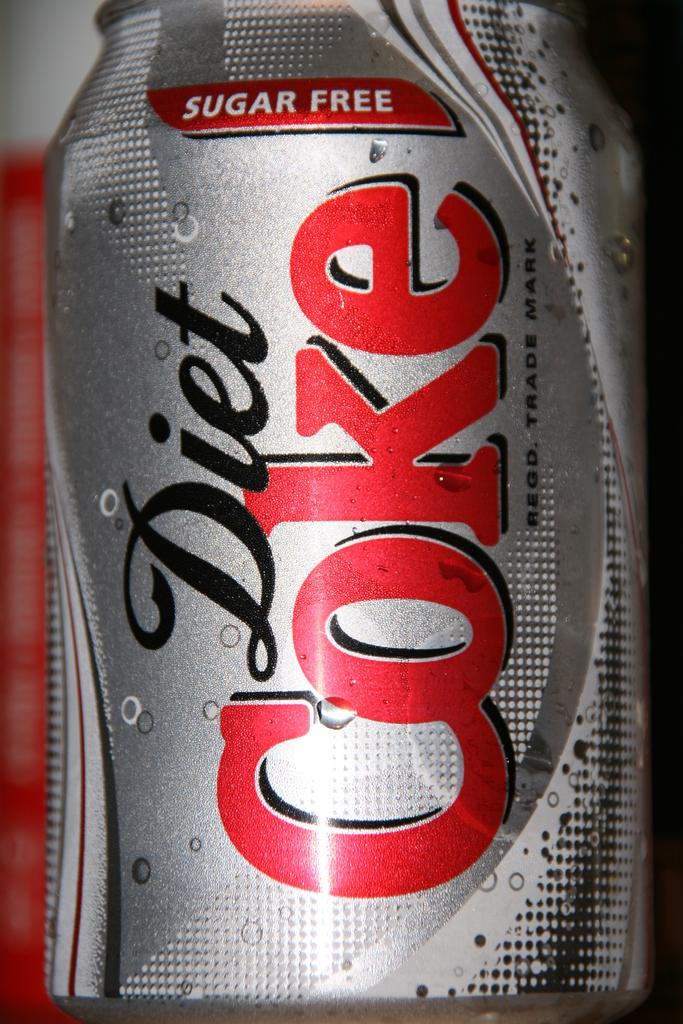<image>
Create a compact narrative representing the image presented. A silver can of Diet Coke claims to be sugar free. 